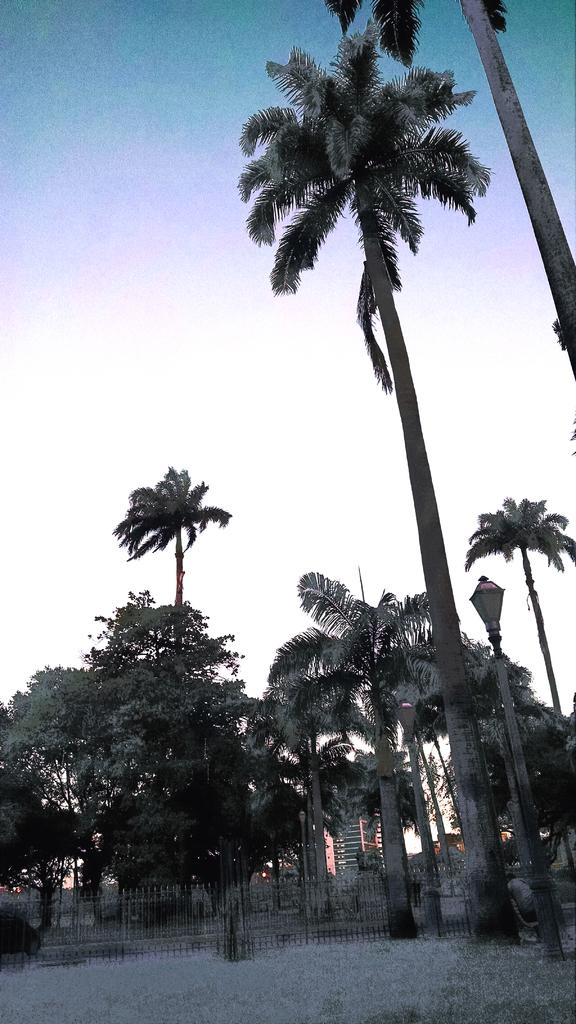What type of structure can be seen in the image? There is a fence in the image. What other natural elements are present in the image? There are trees in the image. Are there any man-made structures visible? Yes, there are poles, lights, and buildings in the image. What can be seen in the background of the image? The sky is visible in the background of the image. Can you see a cart being used by the cat in the image? There is no cart or cat present in the image. What type of fork is being used to eat the food in the image? There is no fork or food present in the image. 